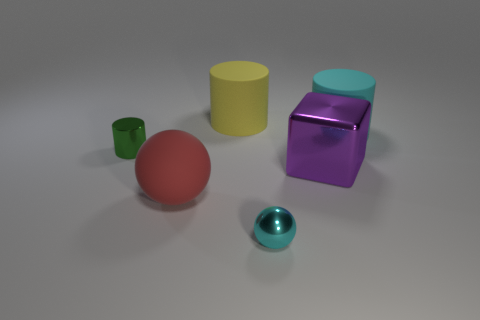Does the small shiny object that is in front of the large red ball have the same color as the big cylinder that is to the right of the big block?
Your response must be concise. Yes. Is the cyan thing that is in front of the big ball made of the same material as the cyan thing right of the cyan sphere?
Your response must be concise. No. What number of cyan balls are the same size as the red sphere?
Your answer should be very brief. 0. Are there fewer big brown matte spheres than metal balls?
Make the answer very short. Yes. What is the shape of the big object behind the matte object right of the metal sphere?
Your answer should be compact. Cylinder. There is a shiny thing that is the same size as the cyan matte thing; what is its shape?
Provide a short and direct response. Cube. Is there a yellow thing of the same shape as the big cyan object?
Give a very brief answer. Yes. What is the purple cube made of?
Your answer should be compact. Metal. Are there any tiny green things behind the small shiny sphere?
Your answer should be compact. Yes. What number of blocks are to the right of the cyan thing that is in front of the tiny metal cylinder?
Your answer should be compact. 1. 